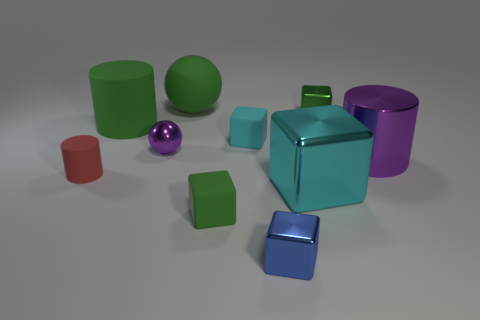There is a ball that is the same size as the red cylinder; what is its color?
Your response must be concise. Purple. Is the number of matte cylinders that are to the right of the big purple cylinder the same as the number of small metal things?
Your answer should be compact. No. What color is the small shiny thing that is behind the purple object on the left side of the cyan metallic thing?
Ensure brevity in your answer.  Green. What size is the green rubber thing behind the big cylinder that is behind the big shiny cylinder?
Make the answer very short. Large. There is a object that is the same color as the metal sphere; what is its size?
Your response must be concise. Large. How many other objects are there of the same size as the green ball?
Give a very brief answer. 3. What is the color of the cube that is on the left side of the tiny cyan thing on the left side of the block to the right of the large cyan shiny cube?
Keep it short and to the point. Green. How many other objects are the same shape as the cyan metallic object?
Ensure brevity in your answer.  4. There is a large thing that is left of the large green matte ball; what shape is it?
Your answer should be very brief. Cylinder. Is there a tiny metal ball behind the cyan thing that is in front of the red matte object?
Provide a short and direct response. Yes. 